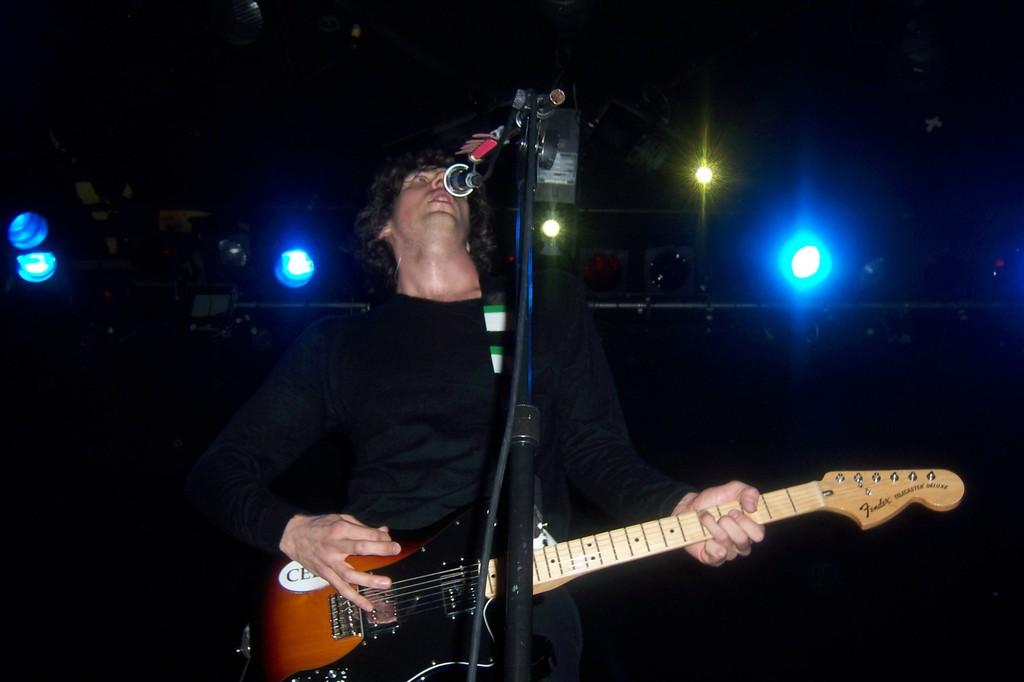What is the man in the image doing? The man is playing a guitar in the image. Can you describe any other objects or features in the image? Yes, there are lights visible in the image. Is there any information about the man's identity? The man's name is likely Mike. How many chair legs can be seen in the image? There is no chair present in the image, so it is not possible to determine the number of chair legs. What type of letters are visible in the image? There are no letters visible in the image. 